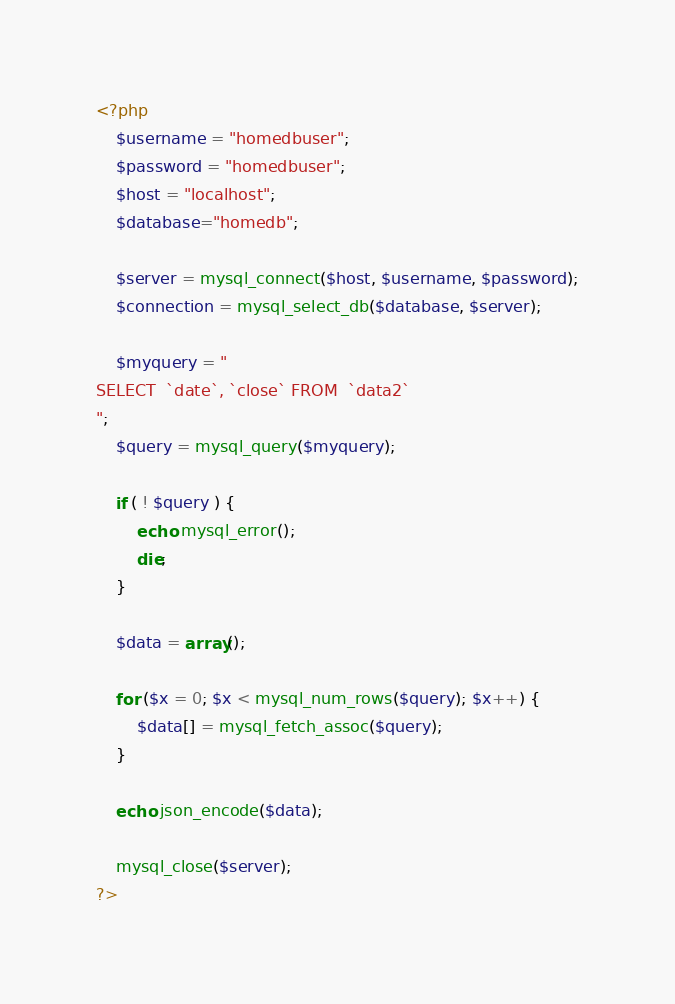<code> <loc_0><loc_0><loc_500><loc_500><_PHP_><?php
    $username = "homedbuser"; 
    $password = "homedbuser";   
    $host = "localhost";
    $database="homedb";
    
    $server = mysql_connect($host, $username, $password);
    $connection = mysql_select_db($database, $server);

    $myquery = "
SELECT  `date`, `close` FROM  `data2`
";
    $query = mysql_query($myquery);
    
    if ( ! $query ) {
        echo mysql_error();
        die;
    }
    
    $data = array();
    
    for ($x = 0; $x < mysql_num_rows($query); $x++) {
        $data[] = mysql_fetch_assoc($query);
    }
    
    echo json_encode($data);     
     
    mysql_close($server);
?>
</code> 